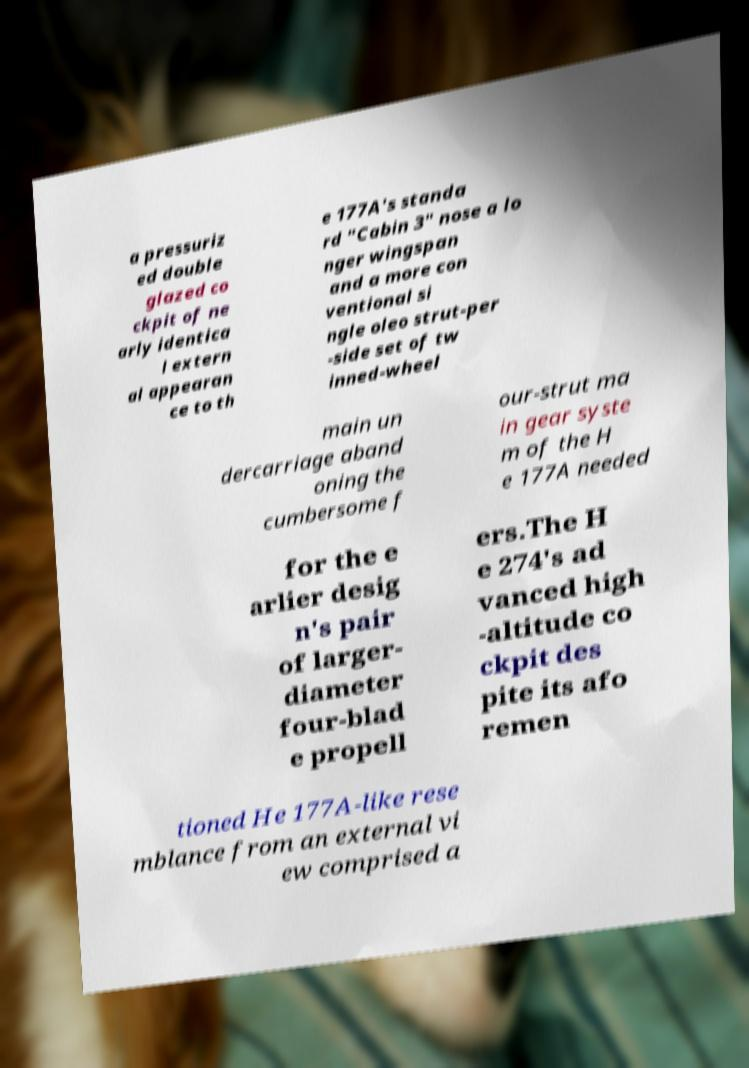For documentation purposes, I need the text within this image transcribed. Could you provide that? a pressuriz ed double glazed co ckpit of ne arly identica l extern al appearan ce to th e 177A's standa rd "Cabin 3" nose a lo nger wingspan and a more con ventional si ngle oleo strut-per -side set of tw inned-wheel main un dercarriage aband oning the cumbersome f our-strut ma in gear syste m of the H e 177A needed for the e arlier desig n's pair of larger- diameter four-blad e propell ers.The H e 274's ad vanced high -altitude co ckpit des pite its afo remen tioned He 177A-like rese mblance from an external vi ew comprised a 